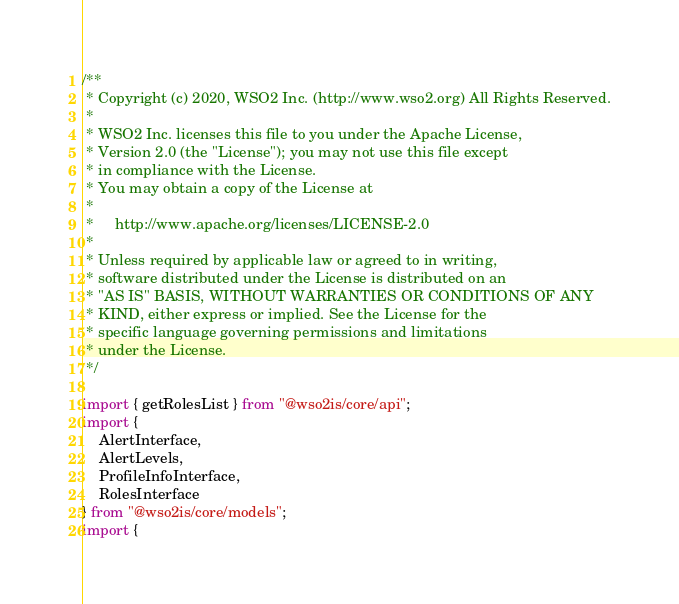Convert code to text. <code><loc_0><loc_0><loc_500><loc_500><_TypeScript_>/**
 * Copyright (c) 2020, WSO2 Inc. (http://www.wso2.org) All Rights Reserved.
 *
 * WSO2 Inc. licenses this file to you under the Apache License,
 * Version 2.0 (the "License"); you may not use this file except
 * in compliance with the License.
 * You may obtain a copy of the License at
 *
 *     http://www.apache.org/licenses/LICENSE-2.0
 *
 * Unless required by applicable law or agreed to in writing,
 * software distributed under the License is distributed on an
 * "AS IS" BASIS, WITHOUT WARRANTIES OR CONDITIONS OF ANY
 * KIND, either express or implied. See the License for the
 * specific language governing permissions and limitations
 * under the License.
 */

import { getRolesList } from "@wso2is/core/api";
import {
    AlertInterface,
    AlertLevels,
    ProfileInfoInterface,
    RolesInterface
} from "@wso2is/core/models";
import {</code> 